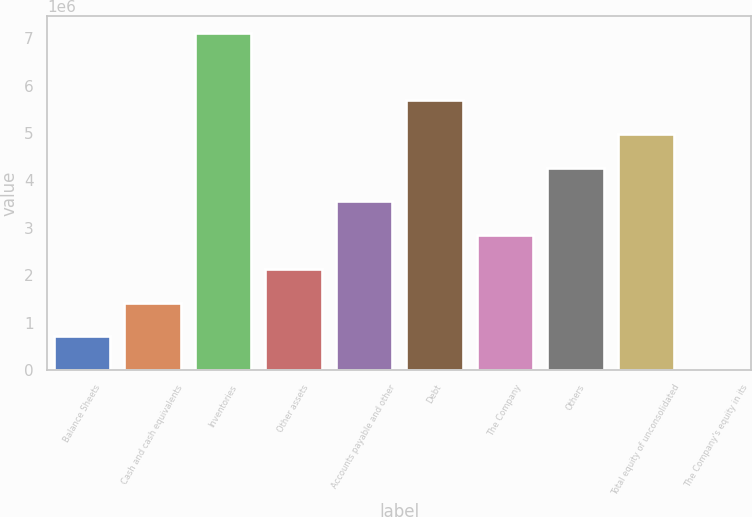Convert chart. <chart><loc_0><loc_0><loc_500><loc_500><bar_chart><fcel>Balance Sheets<fcel>Cash and cash equivalents<fcel>Inventories<fcel>Other assets<fcel>Accounts payable and other<fcel>Debt<fcel>The Company<fcel>Others<fcel>Total equity of unconsolidated<fcel>The Company's equity in its<nl><fcel>711562<fcel>1.4231e+06<fcel>7.11536e+06<fcel>2.13463e+06<fcel>3.55769e+06<fcel>5.69229e+06<fcel>2.84616e+06<fcel>4.26923e+06<fcel>4.98076e+06<fcel>29<nl></chart> 